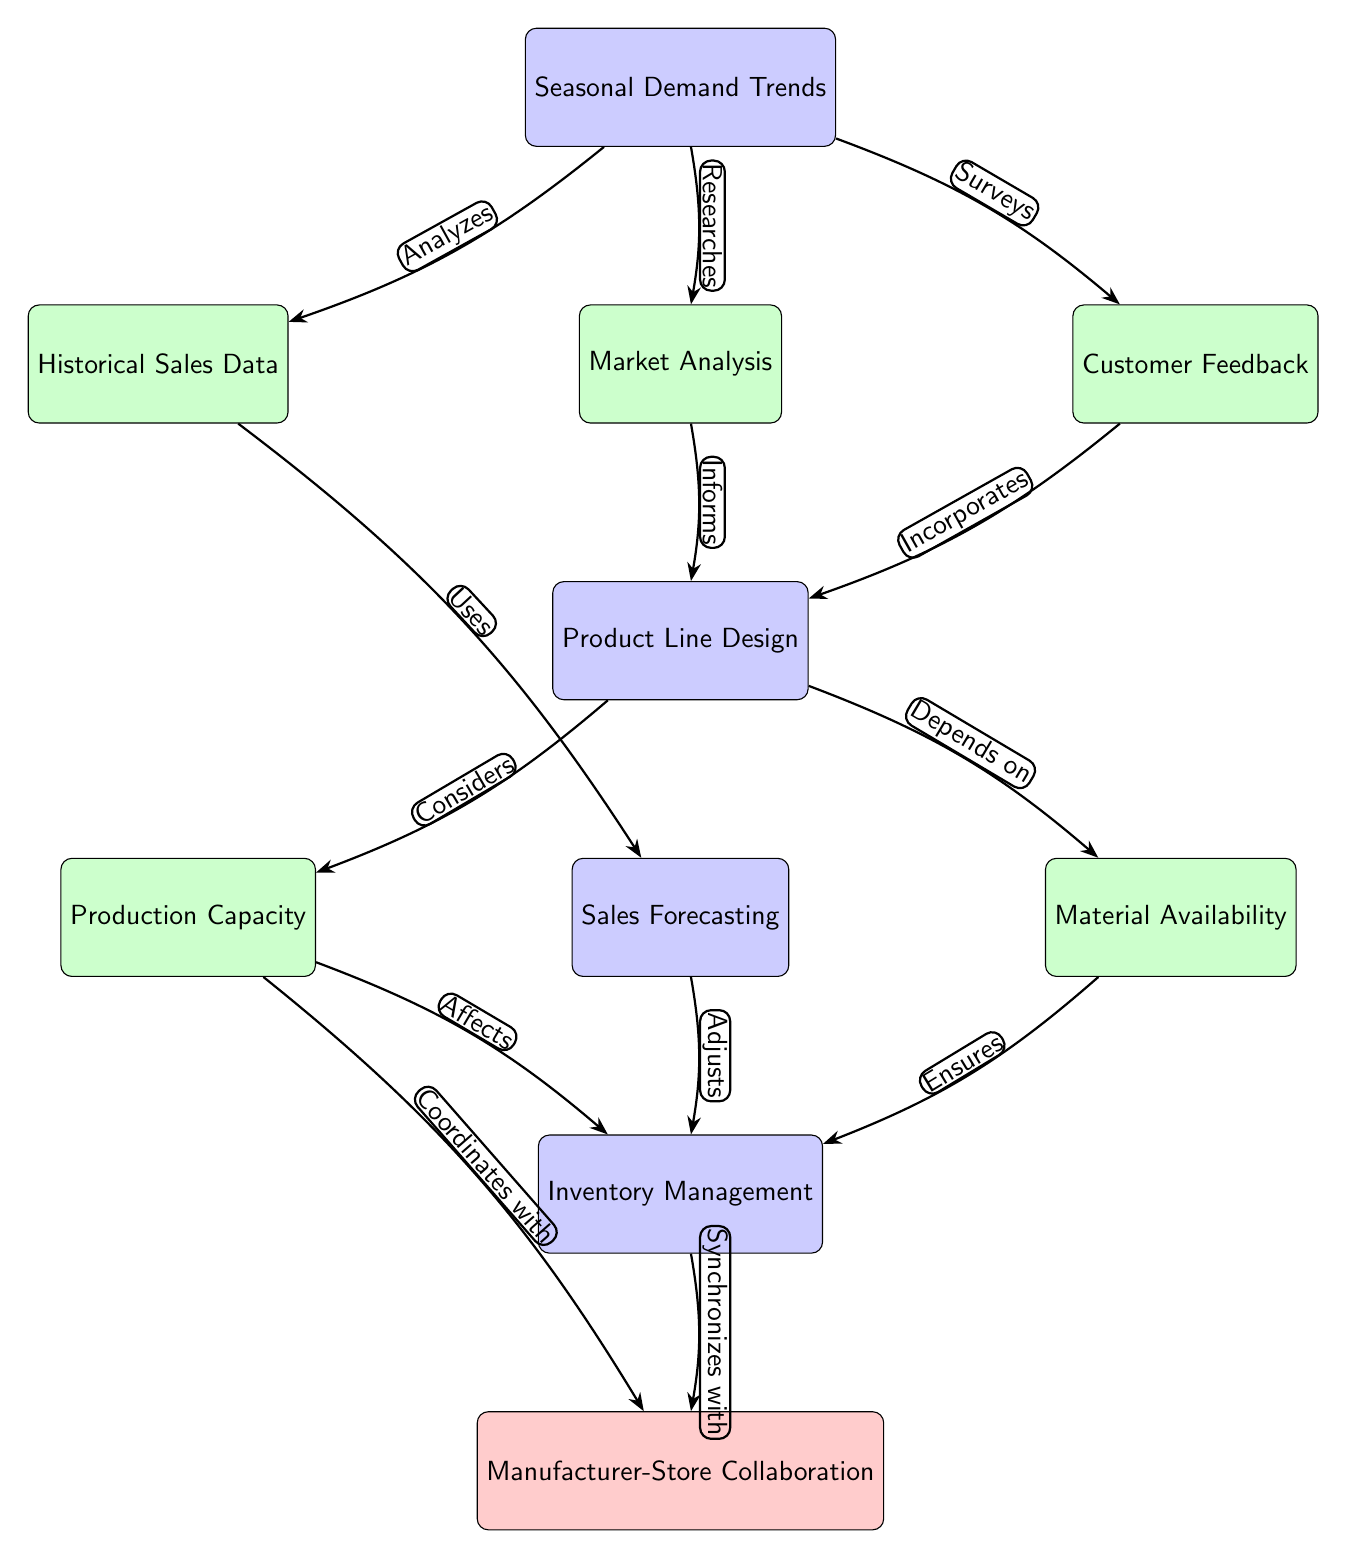What's the main topic of the diagram? The diagram focuses on "Seasonal Demand Trends," which is the primary node positioned at the top. This node connects to various sub-nodes related to analyzing and planning production based on seasonal trends.
Answer: Seasonal Demand Trends How many sub-nodes are directly connected to the main topic? There are three sub-nodes directly connected to the main topic "Seasonal Demand Trends," which include "Historical Sales Data," "Market Analysis," and "Customer Feedback."
Answer: Three What relationship does "Market Analysis" have with "Product Line Design"? "Market Analysis" informs "Product Line Design," indicating that the insights gained from analyzing the market contribute to the decisions made in designing product lines.
Answer: Informs Which node does "Sales Forecasting" connect to? "Sales Forecasting" connects to "Inventory Management," implying that sales predictions are used to manage inventory levels effectively.
Answer: Inventory Management What does "Production Capacity" affect in the diagram? "Production Capacity" affects "Inventory Management," suggesting that the capacity for production influences how inventory is managed and maintained.
Answer: Inventory Management What node do both "Production Capacity" and "Material Availability" relate to? Both "Production Capacity" and "Material Availability" relate to "Product Line Design," indicating that these factors are critical considerations when designing product lines.
Answer: Product Line Design How do "Capacity" and "Inventory" interact with "Manufacturer-Store Collaboration"? "Capacity" coordinates with "Manufacturer-Store Collaboration," and "Inventory" synchronizes with it, indicating that production capabilities and inventory management both play roles in the collaborative efforts between the manufacturer and store owner.
Answer: Coordinates with, Synchronizes with What type of relationship is shown between "Feedback" and "Product Line Design"? The relationship is described as "Incorporates," which means that customer feedback is actively used in the process of designing product lines.
Answer: Incorporates How many total nodes are present in the diagram? The total count of nodes includes both main and sub-nodes, resulting in eight nodes presented in the diagram.
Answer: Eight 